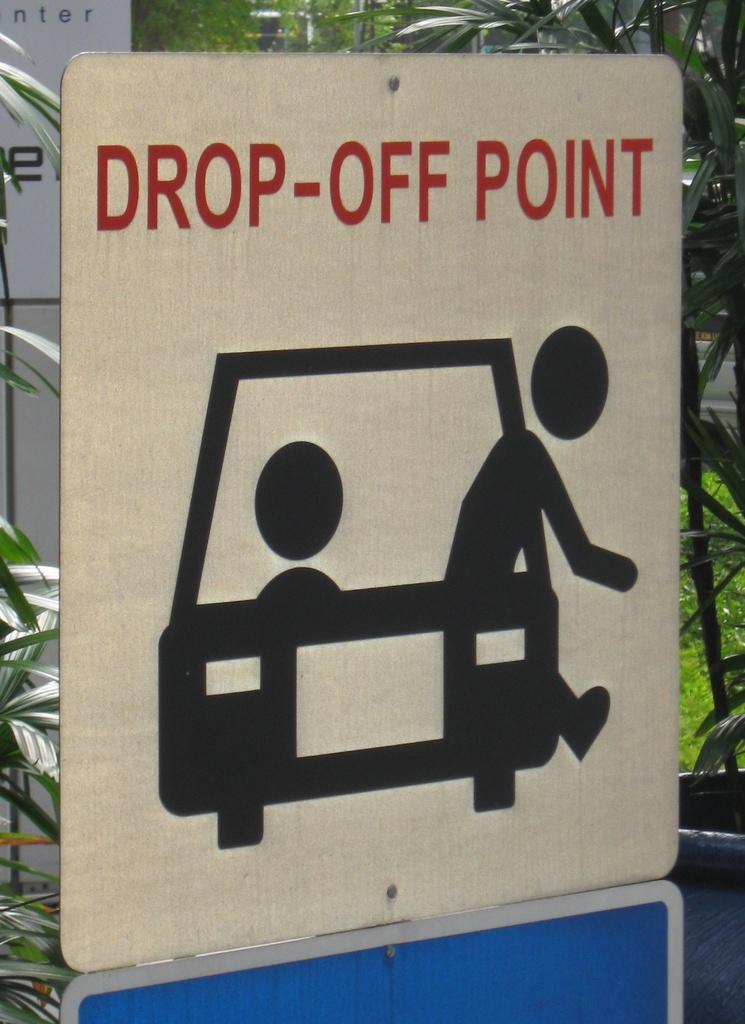<image>
Relay a brief, clear account of the picture shown. An illustrated person exits from a car on a drop-off point sign. 